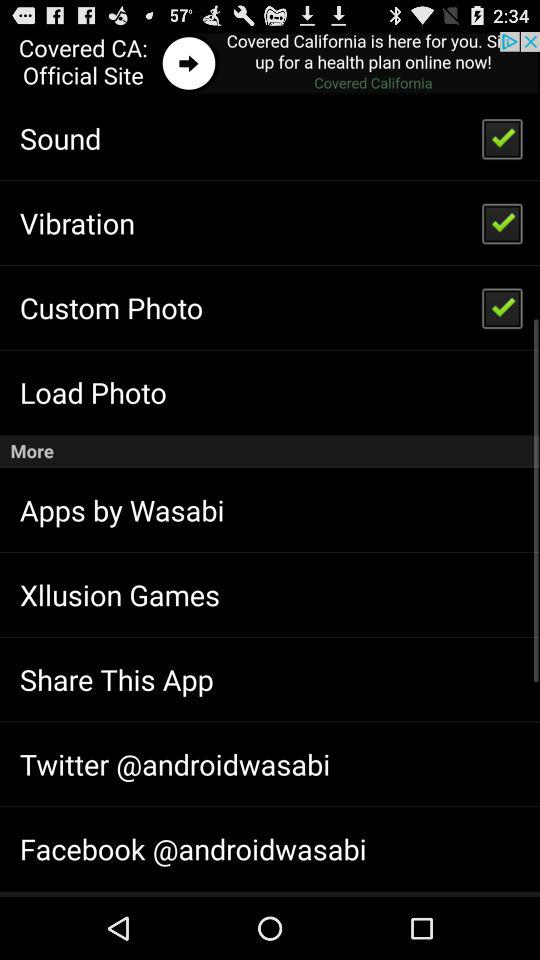What is the status of the "Vibration" setting? The status of the "Vibration" setting is "on". 